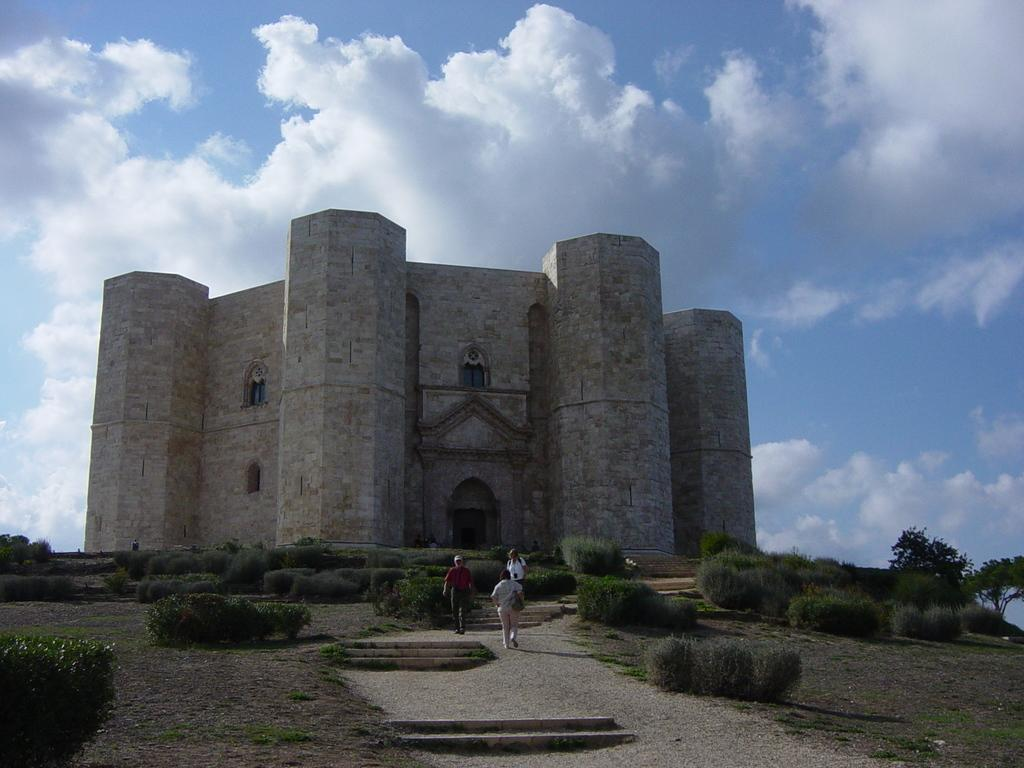What are the people in the image doing? The people in the image are standing on the ground. What is located behind the people? There is a building behind the people. What type of vegetation is present on the ground? There are plants and bushes on the ground. How would you describe the sky in the image? The sky is cloudy in the image. What type of cup can be seen in the hands of the people in the image? There is no cup visible in the hands of the people in the image. Can you describe the fear exhibited by the toad in the image? There is no toad present in the image, and therefore no fear can be observed. 